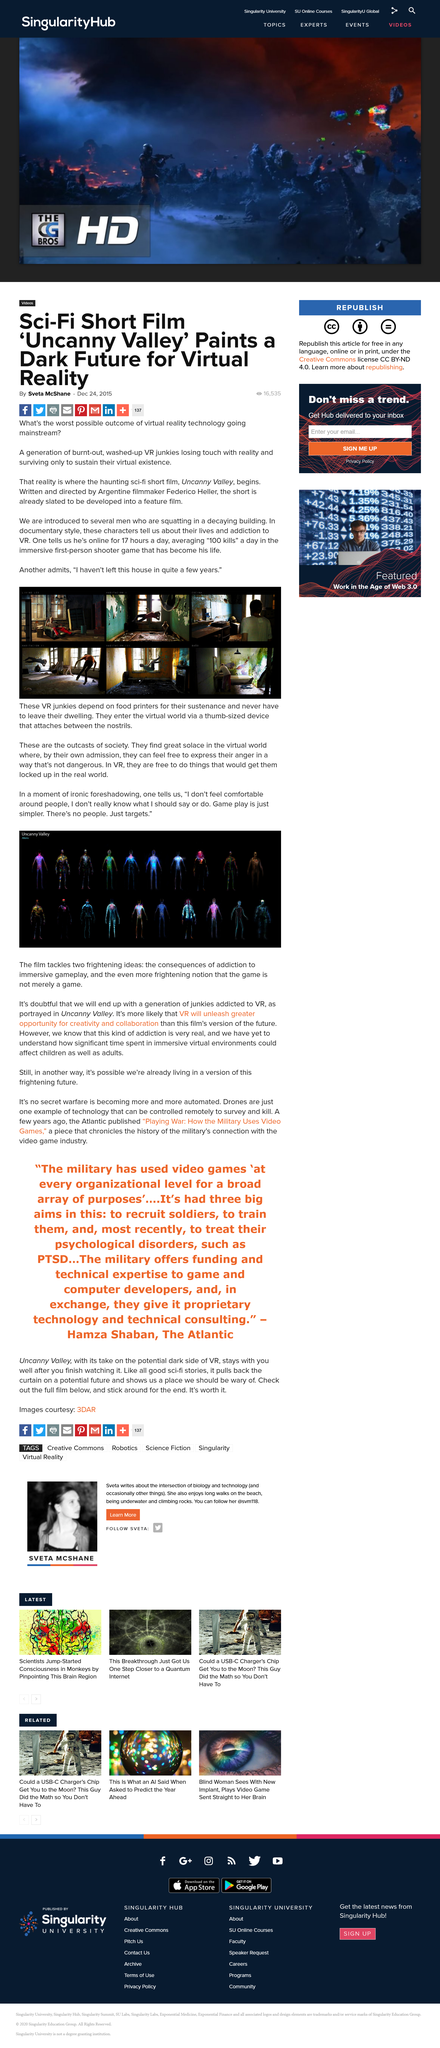Identify some key points in this picture. Gameplay addiction is a real problem in society that affects both children and adults, and we still do not fully understand its effects on society. The article was written by Sveta McShane. The short film is titled "Uncanny Valley. VR junkies find solace in the virtual world because they can freely express their anger in a way that is not dangerous. VR junkies rely solely on food printers for their daily sustenance. 